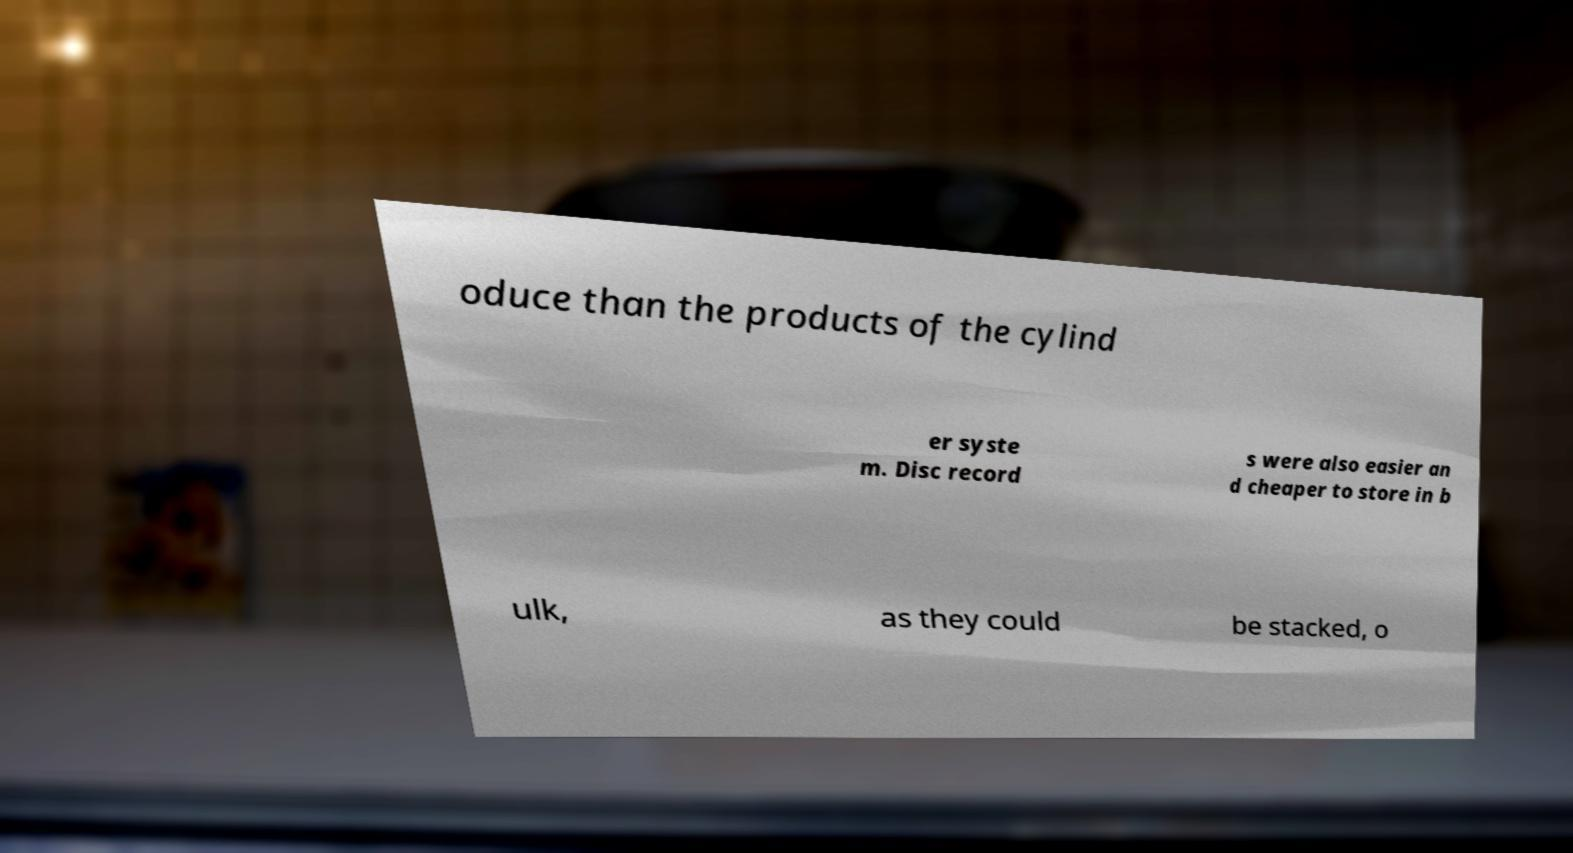Please read and relay the text visible in this image. What does it say? oduce than the products of the cylind er syste m. Disc record s were also easier an d cheaper to store in b ulk, as they could be stacked, o 